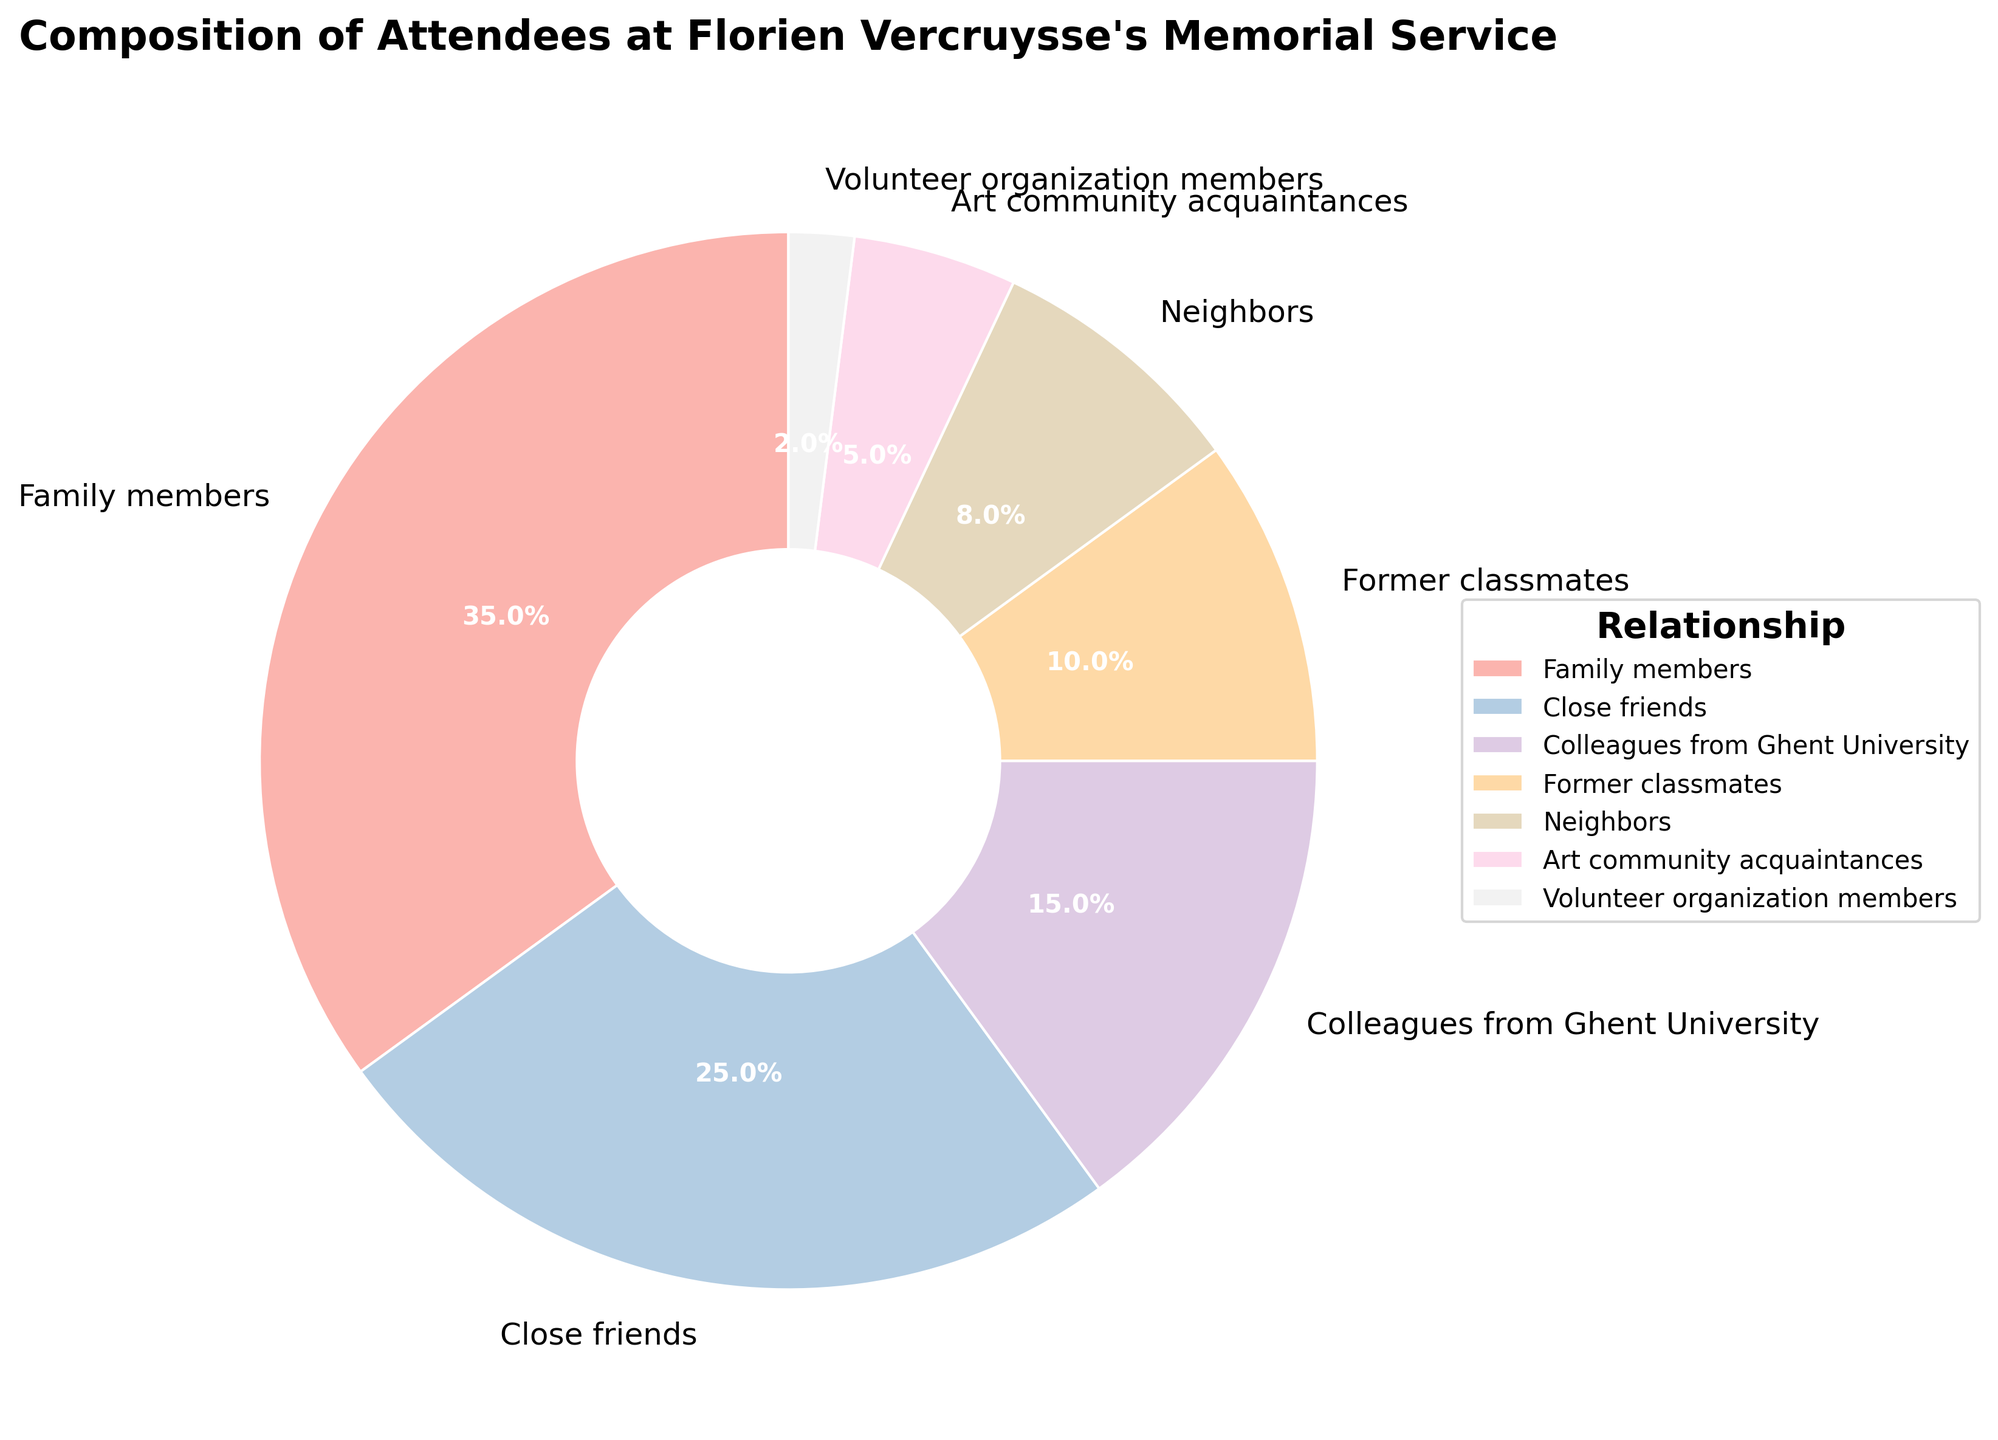What's the largest group of attendees at Florien Vercruysse's memorial service? The largest group can be identified by the segment that represents the highest percentage in the pie chart. Family members occupy the largest segment at 35%.
Answer: Family members Which group has more attendees: Close friends or Colleagues from Ghent University? By comparing the percentages, Close friends have 25% and Colleagues from Ghent University have 15%. 25% is greater than 15%.
Answer: Close friends What is the total percentage of attendees that are either Neighbors or Art community acquaintances? The percentage of Neighbors is 8% and Art community acquaintances is 5%. Adding these together, 8 + 5 = 13%.
Answer: 13% Is the percentage of Close friends greater than the combined percentage of Former classmates and Volunteer organization members? Close friends represent 25%. Former classmates represent 10% and Volunteer organization members 2%. Adding 10% and 2%, we get 12%. 25% is greater than 12%.
Answer: Yes What's the difference in percentage between Family members and Neighbors? Family members are 35% while Neighbors are 8%. Subtracting these, 35% - 8% = 27%.
Answer: 27% What is the average percentage of attendees from Family members, Close friends, and Colleagues from Ghent University? The percentages are Family members 35%, Close friends 25%, and Colleagues from Ghent University 15%. Adding these, 35 + 25 + 15 = 75. Dividing by 3, the average is 75 / 3 = 25%.
Answer: 25% If the segments were ranked by size, which position would Former classmates hold? From largest to smallest: 
1. Family members (35%)
2. Close friends (25%)
3. Colleagues from Ghent University (15%)
4. Former classmates (10%)
... Former classmates are in 4th position.
Answer: 4th How does the percentage of Art community acquaintances compare to that of Former classmates? Art community acquaintances represent 5%, while Former classmates represent 10%. 10% is greater than 5%.
Answer: Less than What's the combined percentage of all attendees who are either Family members, Close friends, or Colleagues from Ghent University? Percentages are Family members 35%, Close friends 25%, and Colleagues from Ghent University 15%. Adding these, 35 + 25 + 15 = 75%.
Answer: 75% What is the smallest group of attendees and what percentage do they represent? The pie chart shows each segment's percentage. Volunteer organization members represent the smallest portion at 2%.
Answer: Volunteer organization members, 2% 